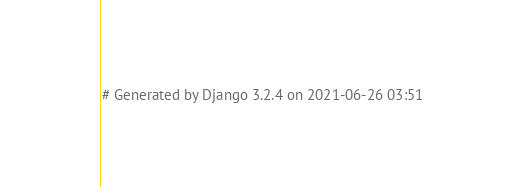Convert code to text. <code><loc_0><loc_0><loc_500><loc_500><_Python_># Generated by Django 3.2.4 on 2021-06-26 03:51
</code> 